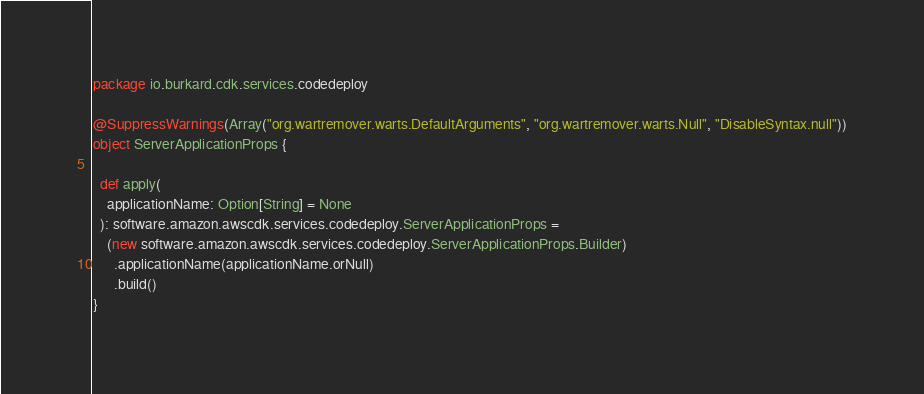Convert code to text. <code><loc_0><loc_0><loc_500><loc_500><_Scala_>package io.burkard.cdk.services.codedeploy

@SuppressWarnings(Array("org.wartremover.warts.DefaultArguments", "org.wartremover.warts.Null", "DisableSyntax.null"))
object ServerApplicationProps {

  def apply(
    applicationName: Option[String] = None
  ): software.amazon.awscdk.services.codedeploy.ServerApplicationProps =
    (new software.amazon.awscdk.services.codedeploy.ServerApplicationProps.Builder)
      .applicationName(applicationName.orNull)
      .build()
}
</code> 